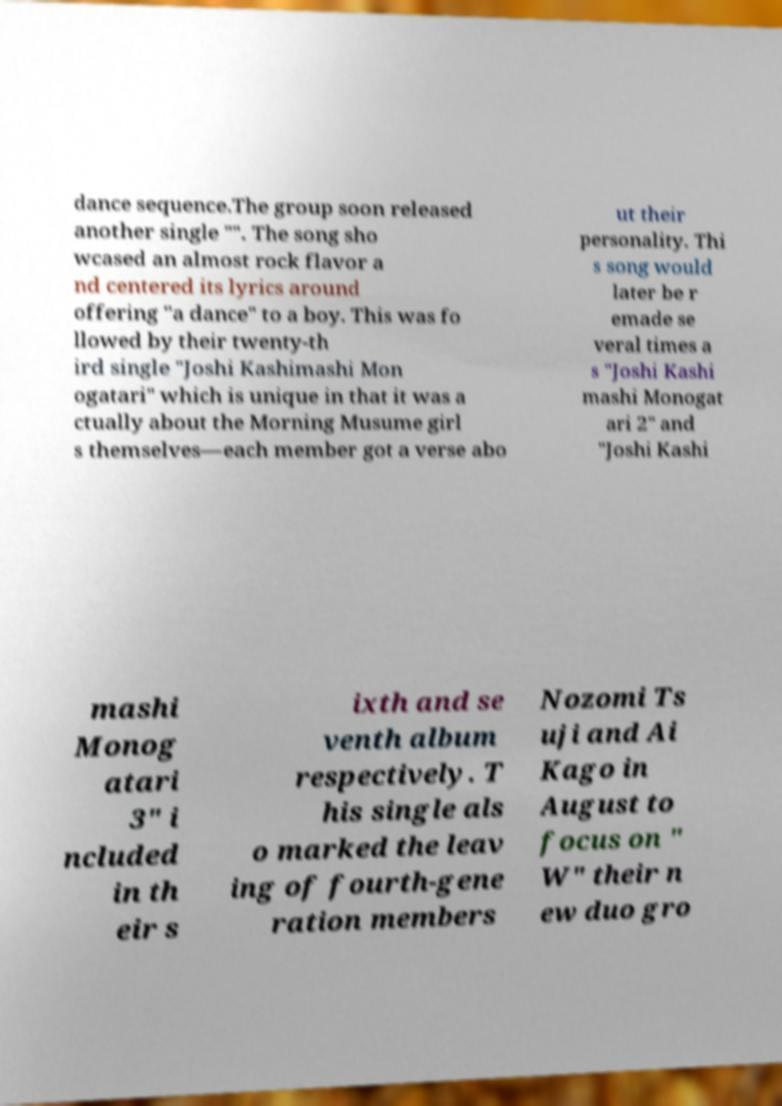I need the written content from this picture converted into text. Can you do that? dance sequence.The group soon released another single "". The song sho wcased an almost rock flavor a nd centered its lyrics around offering "a dance" to a boy. This was fo llowed by their twenty-th ird single "Joshi Kashimashi Mon ogatari" which is unique in that it was a ctually about the Morning Musume girl s themselves—each member got a verse abo ut their personality. Thi s song would later be r emade se veral times a s "Joshi Kashi mashi Monogat ari 2" and "Joshi Kashi mashi Monog atari 3" i ncluded in th eir s ixth and se venth album respectively. T his single als o marked the leav ing of fourth-gene ration members Nozomi Ts uji and Ai Kago in August to focus on " W" their n ew duo gro 